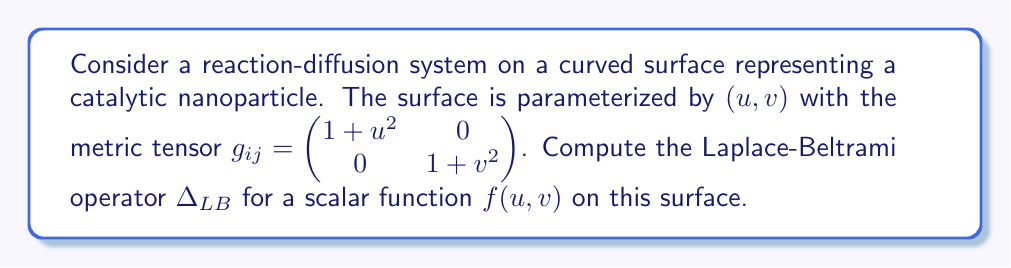Show me your answer to this math problem. To compute the Laplace-Beltrami operator, we'll follow these steps:

1) The Laplace-Beltrami operator is given by:

   $$\Delta_{LB}f = \frac{1}{\sqrt{|g|}} \partial_i (\sqrt{|g|} g^{ij} \partial_j f)$$

   where $g$ is the determinant of the metric tensor, and $g^{ij}$ is the inverse metric tensor.

2) First, let's calculate $|g|$:
   $$|g| = (1+u^2)(1+v^2)$$

3) Now, we need to find $\sqrt{|g|}$:
   $$\sqrt{|g|} = \sqrt{(1+u^2)(1+v^2)}$$

4) Next, we calculate the inverse metric tensor $g^{ij}$:
   $$g^{ij} = \begin{pmatrix} \frac{1}{1+u^2} & 0 \\ 0 & \frac{1}{1+v^2} \end{pmatrix}$$

5) Now, let's expand the Laplace-Beltrami operator:

   $$\Delta_{LB}f = \frac{1}{\sqrt{(1+u^2)(1+v^2)}} \left[\frac{\partial}{\partial u}\left(\sqrt{(1+u^2)(1+v^2)} \cdot \frac{1}{1+u^2} \cdot \frac{\partial f}{\partial u}\right) + \frac{\partial}{\partial v}\left(\sqrt{(1+u^2)(1+v^2)} \cdot \frac{1}{1+v^2} \cdot \frac{\partial f}{\partial v}\right)\right]$$

6) Simplifying:

   $$\Delta_{LB}f = \frac{1}{\sqrt{(1+u^2)(1+v^2)}} \left[\frac{\partial}{\partial u}\left(\sqrt{\frac{1+v^2}{1+u^2}} \cdot \frac{\partial f}{\partial u}\right) + \frac{\partial}{\partial v}\left(\sqrt{\frac{1+u^2}{1+v^2}} \cdot \frac{\partial f}{\partial v}\right)\right]$$

This is the Laplace-Beltrami operator for the given curved surface.
Answer: $$\Delta_{LB}f = \frac{1}{\sqrt{(1+u^2)(1+v^2)}} \left[\frac{\partial}{\partial u}\left(\sqrt{\frac{1+v^2}{1+u^2}} \cdot \frac{\partial f}{\partial u}\right) + \frac{\partial}{\partial v}\left(\sqrt{\frac{1+u^2}{1+v^2}} \cdot \frac{\partial f}{\partial v}\right)\right]$$ 